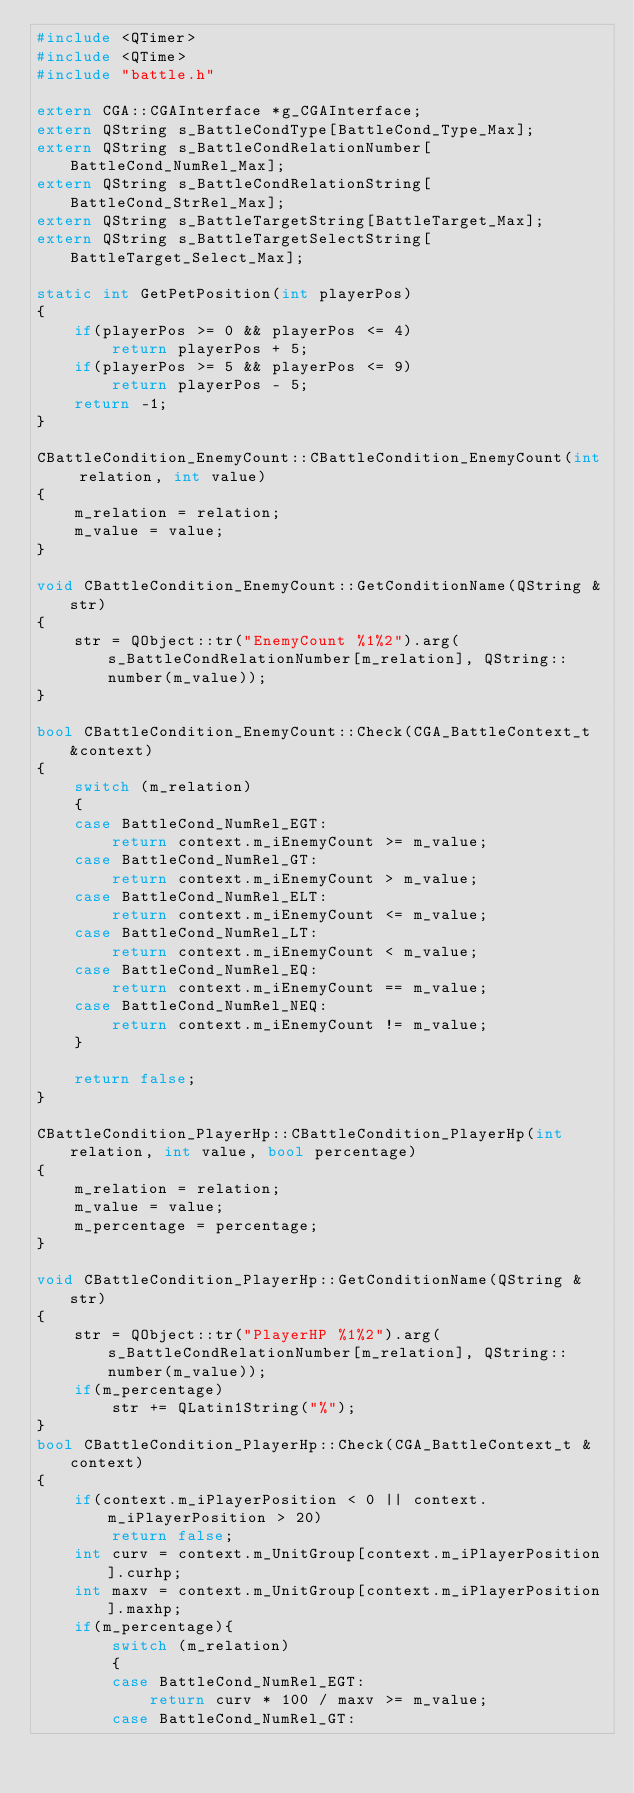Convert code to text. <code><loc_0><loc_0><loc_500><loc_500><_C++_>#include <QTimer>
#include <QTime>
#include "battle.h"

extern CGA::CGAInterface *g_CGAInterface;
extern QString s_BattleCondType[BattleCond_Type_Max];
extern QString s_BattleCondRelationNumber[BattleCond_NumRel_Max];
extern QString s_BattleCondRelationString[BattleCond_StrRel_Max];
extern QString s_BattleTargetString[BattleTarget_Max];
extern QString s_BattleTargetSelectString[BattleTarget_Select_Max];

static int GetPetPosition(int playerPos)
{
    if(playerPos >= 0 && playerPos <= 4)
        return playerPos + 5;
    if(playerPos >= 5 && playerPos <= 9)
        return playerPos - 5;
    return -1;
}

CBattleCondition_EnemyCount::CBattleCondition_EnemyCount(int relation, int value)
{
    m_relation = relation;
    m_value = value;
}

void CBattleCondition_EnemyCount::GetConditionName(QString &str)
{
    str = QObject::tr("EnemyCount %1%2").arg(s_BattleCondRelationNumber[m_relation], QString::number(m_value));
}

bool CBattleCondition_EnemyCount::Check(CGA_BattleContext_t &context)
{
    switch (m_relation)
    {
    case BattleCond_NumRel_EGT:
        return context.m_iEnemyCount >= m_value;
    case BattleCond_NumRel_GT:
        return context.m_iEnemyCount > m_value;
    case BattleCond_NumRel_ELT:
        return context.m_iEnemyCount <= m_value;
    case BattleCond_NumRel_LT:
        return context.m_iEnemyCount < m_value;
    case BattleCond_NumRel_EQ:
        return context.m_iEnemyCount == m_value;
    case BattleCond_NumRel_NEQ:
        return context.m_iEnemyCount != m_value;
    }

    return false;
}

CBattleCondition_PlayerHp::CBattleCondition_PlayerHp(int relation, int value, bool percentage)
{
    m_relation = relation;
    m_value = value;
    m_percentage = percentage;
}

void CBattleCondition_PlayerHp::GetConditionName(QString &str)
{
    str = QObject::tr("PlayerHP %1%2").arg(s_BattleCondRelationNumber[m_relation], QString::number(m_value));
    if(m_percentage)
        str += QLatin1String("%");
}
bool CBattleCondition_PlayerHp::Check(CGA_BattleContext_t &context)
{
    if(context.m_iPlayerPosition < 0 || context.m_iPlayerPosition > 20)
        return false;
    int curv = context.m_UnitGroup[context.m_iPlayerPosition].curhp;
    int maxv = context.m_UnitGroup[context.m_iPlayerPosition].maxhp;
    if(m_percentage){
        switch (m_relation)
        {
        case BattleCond_NumRel_EGT:
            return curv * 100 / maxv >= m_value;
        case BattleCond_NumRel_GT:</code> 